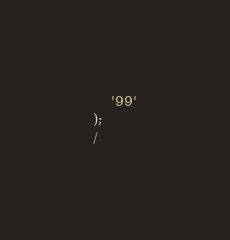Convert code to text. <code><loc_0><loc_0><loc_500><loc_500><_SQL_>    '99'
);
/</code> 